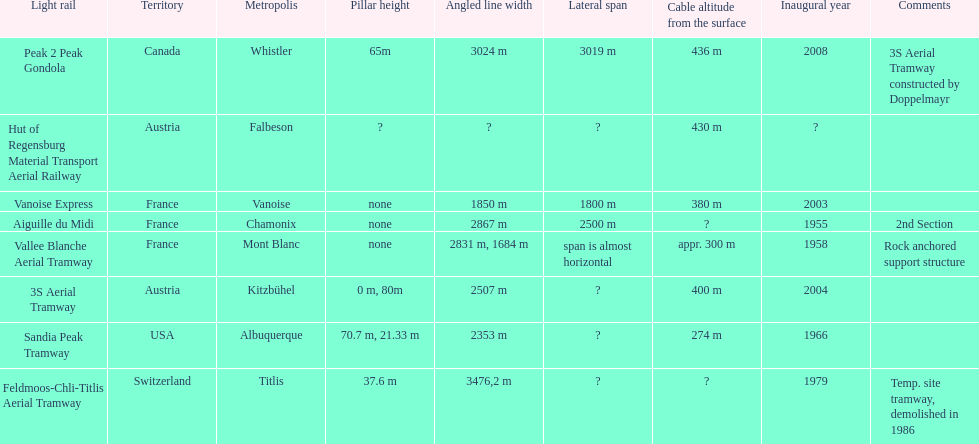How much greater is the height of cable over ground measurement for the peak 2 peak gondola when compared with that of the vanoise express? 56 m. Can you parse all the data within this table? {'header': ['Light rail', 'Territory', 'Metropolis', 'Pillar height', 'Angled line width', 'Lateral span', 'Cable altitude from the surface', 'Inaugural year', 'Comments'], 'rows': [['Peak 2 Peak Gondola', 'Canada', 'Whistler', '65m', '3024 m', '3019 m', '436 m', '2008', '3S Aerial Tramway constructed by Doppelmayr'], ['Hut of Regensburg Material Transport Aerial Railway', 'Austria', 'Falbeson', '?', '?', '?', '430 m', '?', ''], ['Vanoise Express', 'France', 'Vanoise', 'none', '1850 m', '1800 m', '380 m', '2003', ''], ['Aiguille du Midi', 'France', 'Chamonix', 'none', '2867 m', '2500 m', '?', '1955', '2nd Section'], ['Vallee Blanche Aerial Tramway', 'France', 'Mont Blanc', 'none', '2831 m, 1684 m', 'span is almost horizontal', 'appr. 300 m', '1958', 'Rock anchored support structure'], ['3S Aerial Tramway', 'Austria', 'Kitzbühel', '0 m, 80m', '2507 m', '?', '400 m', '2004', ''], ['Sandia Peak Tramway', 'USA', 'Albuquerque', '70.7 m, 21.33 m', '2353 m', '?', '274 m', '1966', ''], ['Feldmoos-Chli-Titlis Aerial Tramway', 'Switzerland', 'Titlis', '37.6 m', '3476,2 m', '?', '?', '1979', 'Temp. site tramway, demolished in 1986']]} 